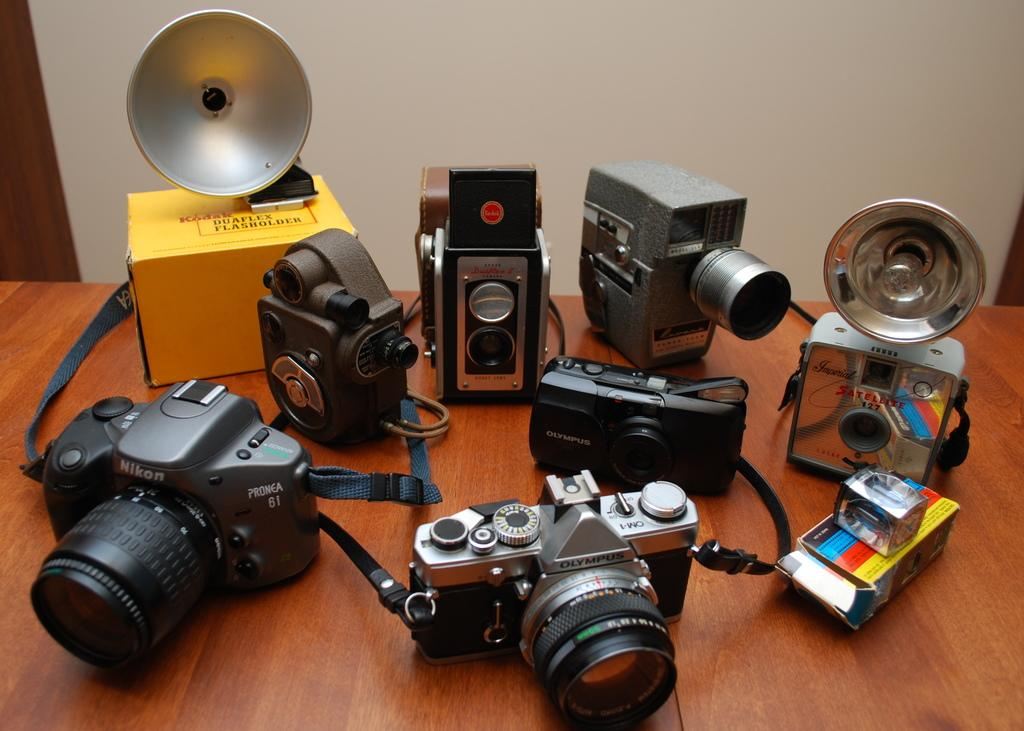What can be seen on the table in the image? There are different types of cameras and lenses on the table. Are there any other objects on the table besides cameras and lenses? Yes, there are other objects on the table. What is visible at the top of the image? There is a wall at the top of the image. What type of flag is being waved by the boy in the image? There is no flag or boy present in the image; it only features cameras, lenses, and other objects on a table with a wall in the background. 